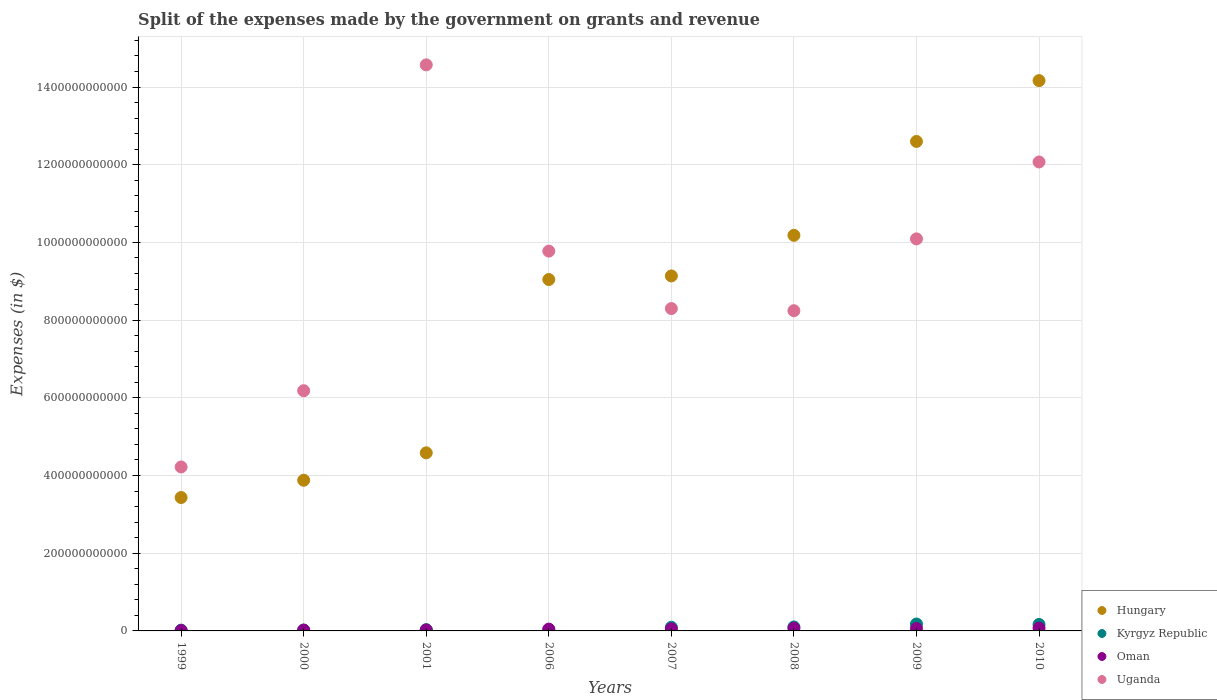How many different coloured dotlines are there?
Provide a succinct answer. 4. Is the number of dotlines equal to the number of legend labels?
Give a very brief answer. Yes. What is the expenses made by the government on grants and revenue in Oman in 1999?
Offer a terse response. 9.96e+08. Across all years, what is the maximum expenses made by the government on grants and revenue in Kyrgyz Republic?
Your answer should be compact. 1.78e+1. Across all years, what is the minimum expenses made by the government on grants and revenue in Uganda?
Give a very brief answer. 4.22e+11. In which year was the expenses made by the government on grants and revenue in Kyrgyz Republic maximum?
Make the answer very short. 2009. In which year was the expenses made by the government on grants and revenue in Kyrgyz Republic minimum?
Make the answer very short. 1999. What is the total expenses made by the government on grants and revenue in Hungary in the graph?
Ensure brevity in your answer.  6.70e+12. What is the difference between the expenses made by the government on grants and revenue in Uganda in 2000 and that in 2008?
Ensure brevity in your answer.  -2.06e+11. What is the difference between the expenses made by the government on grants and revenue in Uganda in 2006 and the expenses made by the government on grants and revenue in Hungary in 2010?
Give a very brief answer. -4.39e+11. What is the average expenses made by the government on grants and revenue in Uganda per year?
Offer a very short reply. 9.18e+11. In the year 2007, what is the difference between the expenses made by the government on grants and revenue in Uganda and expenses made by the government on grants and revenue in Oman?
Offer a very short reply. 8.24e+11. In how many years, is the expenses made by the government on grants and revenue in Oman greater than 280000000000 $?
Offer a very short reply. 0. What is the ratio of the expenses made by the government on grants and revenue in Kyrgyz Republic in 2000 to that in 2008?
Keep it short and to the point. 0.21. Is the difference between the expenses made by the government on grants and revenue in Uganda in 1999 and 2009 greater than the difference between the expenses made by the government on grants and revenue in Oman in 1999 and 2009?
Keep it short and to the point. No. What is the difference between the highest and the second highest expenses made by the government on grants and revenue in Kyrgyz Republic?
Your answer should be very brief. 1.05e+09. What is the difference between the highest and the lowest expenses made by the government on grants and revenue in Kyrgyz Republic?
Your answer should be compact. 1.57e+1. Is it the case that in every year, the sum of the expenses made by the government on grants and revenue in Oman and expenses made by the government on grants and revenue in Uganda  is greater than the expenses made by the government on grants and revenue in Kyrgyz Republic?
Ensure brevity in your answer.  Yes. Is the expenses made by the government on grants and revenue in Oman strictly less than the expenses made by the government on grants and revenue in Kyrgyz Republic over the years?
Your response must be concise. No. How many dotlines are there?
Keep it short and to the point. 4. What is the difference between two consecutive major ticks on the Y-axis?
Your response must be concise. 2.00e+11. Does the graph contain any zero values?
Ensure brevity in your answer.  No. Where does the legend appear in the graph?
Your answer should be very brief. Bottom right. What is the title of the graph?
Make the answer very short. Split of the expenses made by the government on grants and revenue. Does "Samoa" appear as one of the legend labels in the graph?
Offer a terse response. No. What is the label or title of the Y-axis?
Give a very brief answer. Expenses (in $). What is the Expenses (in $) in Hungary in 1999?
Ensure brevity in your answer.  3.43e+11. What is the Expenses (in $) of Kyrgyz Republic in 1999?
Provide a short and direct response. 2.05e+09. What is the Expenses (in $) of Oman in 1999?
Offer a terse response. 9.96e+08. What is the Expenses (in $) of Uganda in 1999?
Offer a terse response. 4.22e+11. What is the Expenses (in $) in Hungary in 2000?
Keep it short and to the point. 3.88e+11. What is the Expenses (in $) in Kyrgyz Republic in 2000?
Keep it short and to the point. 2.19e+09. What is the Expenses (in $) in Oman in 2000?
Provide a succinct answer. 2.13e+09. What is the Expenses (in $) in Uganda in 2000?
Ensure brevity in your answer.  6.18e+11. What is the Expenses (in $) in Hungary in 2001?
Your answer should be very brief. 4.58e+11. What is the Expenses (in $) of Kyrgyz Republic in 2001?
Your response must be concise. 3.29e+09. What is the Expenses (in $) of Oman in 2001?
Provide a short and direct response. 2.38e+09. What is the Expenses (in $) in Uganda in 2001?
Keep it short and to the point. 1.46e+12. What is the Expenses (in $) in Hungary in 2006?
Provide a succinct answer. 9.05e+11. What is the Expenses (in $) in Kyrgyz Republic in 2006?
Ensure brevity in your answer.  2.90e+09. What is the Expenses (in $) of Oman in 2006?
Provide a short and direct response. 4.63e+09. What is the Expenses (in $) in Uganda in 2006?
Provide a short and direct response. 9.78e+11. What is the Expenses (in $) of Hungary in 2007?
Give a very brief answer. 9.14e+11. What is the Expenses (in $) of Kyrgyz Republic in 2007?
Your answer should be very brief. 9.40e+09. What is the Expenses (in $) in Oman in 2007?
Offer a very short reply. 5.40e+09. What is the Expenses (in $) in Uganda in 2007?
Your answer should be very brief. 8.30e+11. What is the Expenses (in $) of Hungary in 2008?
Your response must be concise. 1.02e+12. What is the Expenses (in $) of Kyrgyz Republic in 2008?
Your answer should be compact. 1.03e+1. What is the Expenses (in $) in Oman in 2008?
Make the answer very short. 7.02e+09. What is the Expenses (in $) in Uganda in 2008?
Your answer should be very brief. 8.24e+11. What is the Expenses (in $) of Hungary in 2009?
Provide a short and direct response. 1.26e+12. What is the Expenses (in $) in Kyrgyz Republic in 2009?
Give a very brief answer. 1.78e+1. What is the Expenses (in $) of Oman in 2009?
Your response must be concise. 6.14e+09. What is the Expenses (in $) of Uganda in 2009?
Offer a terse response. 1.01e+12. What is the Expenses (in $) of Hungary in 2010?
Ensure brevity in your answer.  1.42e+12. What is the Expenses (in $) of Kyrgyz Republic in 2010?
Ensure brevity in your answer.  1.67e+1. What is the Expenses (in $) of Oman in 2010?
Provide a succinct answer. 7.31e+09. What is the Expenses (in $) of Uganda in 2010?
Ensure brevity in your answer.  1.21e+12. Across all years, what is the maximum Expenses (in $) in Hungary?
Keep it short and to the point. 1.42e+12. Across all years, what is the maximum Expenses (in $) of Kyrgyz Republic?
Ensure brevity in your answer.  1.78e+1. Across all years, what is the maximum Expenses (in $) of Oman?
Your answer should be compact. 7.31e+09. Across all years, what is the maximum Expenses (in $) in Uganda?
Ensure brevity in your answer.  1.46e+12. Across all years, what is the minimum Expenses (in $) of Hungary?
Offer a terse response. 3.43e+11. Across all years, what is the minimum Expenses (in $) of Kyrgyz Republic?
Your response must be concise. 2.05e+09. Across all years, what is the minimum Expenses (in $) in Oman?
Offer a very short reply. 9.96e+08. Across all years, what is the minimum Expenses (in $) in Uganda?
Your answer should be compact. 4.22e+11. What is the total Expenses (in $) in Hungary in the graph?
Give a very brief answer. 6.70e+12. What is the total Expenses (in $) of Kyrgyz Republic in the graph?
Your answer should be compact. 6.46e+1. What is the total Expenses (in $) of Oman in the graph?
Offer a terse response. 3.60e+1. What is the total Expenses (in $) of Uganda in the graph?
Provide a short and direct response. 7.35e+12. What is the difference between the Expenses (in $) in Hungary in 1999 and that in 2000?
Ensure brevity in your answer.  -4.44e+1. What is the difference between the Expenses (in $) of Kyrgyz Republic in 1999 and that in 2000?
Offer a very short reply. -1.39e+08. What is the difference between the Expenses (in $) of Oman in 1999 and that in 2000?
Provide a short and direct response. -1.13e+09. What is the difference between the Expenses (in $) in Uganda in 1999 and that in 2000?
Give a very brief answer. -1.96e+11. What is the difference between the Expenses (in $) in Hungary in 1999 and that in 2001?
Offer a very short reply. -1.15e+11. What is the difference between the Expenses (in $) in Kyrgyz Republic in 1999 and that in 2001?
Offer a very short reply. -1.24e+09. What is the difference between the Expenses (in $) of Oman in 1999 and that in 2001?
Ensure brevity in your answer.  -1.39e+09. What is the difference between the Expenses (in $) of Uganda in 1999 and that in 2001?
Provide a short and direct response. -1.04e+12. What is the difference between the Expenses (in $) in Hungary in 1999 and that in 2006?
Offer a very short reply. -5.61e+11. What is the difference between the Expenses (in $) of Kyrgyz Republic in 1999 and that in 2006?
Offer a terse response. -8.53e+08. What is the difference between the Expenses (in $) in Oman in 1999 and that in 2006?
Provide a short and direct response. -3.64e+09. What is the difference between the Expenses (in $) in Uganda in 1999 and that in 2006?
Give a very brief answer. -5.56e+11. What is the difference between the Expenses (in $) of Hungary in 1999 and that in 2007?
Provide a short and direct response. -5.70e+11. What is the difference between the Expenses (in $) of Kyrgyz Republic in 1999 and that in 2007?
Provide a short and direct response. -7.35e+09. What is the difference between the Expenses (in $) in Oman in 1999 and that in 2007?
Ensure brevity in your answer.  -4.40e+09. What is the difference between the Expenses (in $) in Uganda in 1999 and that in 2007?
Keep it short and to the point. -4.08e+11. What is the difference between the Expenses (in $) in Hungary in 1999 and that in 2008?
Provide a short and direct response. -6.75e+11. What is the difference between the Expenses (in $) of Kyrgyz Republic in 1999 and that in 2008?
Provide a succinct answer. -8.21e+09. What is the difference between the Expenses (in $) in Oman in 1999 and that in 2008?
Your response must be concise. -6.02e+09. What is the difference between the Expenses (in $) in Uganda in 1999 and that in 2008?
Your answer should be compact. -4.02e+11. What is the difference between the Expenses (in $) in Hungary in 1999 and that in 2009?
Offer a terse response. -9.17e+11. What is the difference between the Expenses (in $) in Kyrgyz Republic in 1999 and that in 2009?
Your answer should be compact. -1.57e+1. What is the difference between the Expenses (in $) of Oman in 1999 and that in 2009?
Your answer should be very brief. -5.14e+09. What is the difference between the Expenses (in $) of Uganda in 1999 and that in 2009?
Offer a terse response. -5.87e+11. What is the difference between the Expenses (in $) in Hungary in 1999 and that in 2010?
Ensure brevity in your answer.  -1.07e+12. What is the difference between the Expenses (in $) in Kyrgyz Republic in 1999 and that in 2010?
Your response must be concise. -1.47e+1. What is the difference between the Expenses (in $) in Oman in 1999 and that in 2010?
Provide a succinct answer. -6.31e+09. What is the difference between the Expenses (in $) in Uganda in 1999 and that in 2010?
Keep it short and to the point. -7.85e+11. What is the difference between the Expenses (in $) of Hungary in 2000 and that in 2001?
Keep it short and to the point. -7.05e+1. What is the difference between the Expenses (in $) of Kyrgyz Republic in 2000 and that in 2001?
Provide a short and direct response. -1.11e+09. What is the difference between the Expenses (in $) in Oman in 2000 and that in 2001?
Offer a terse response. -2.54e+08. What is the difference between the Expenses (in $) of Uganda in 2000 and that in 2001?
Your answer should be compact. -8.39e+11. What is the difference between the Expenses (in $) in Hungary in 2000 and that in 2006?
Make the answer very short. -5.17e+11. What is the difference between the Expenses (in $) of Kyrgyz Republic in 2000 and that in 2006?
Your answer should be compact. -7.14e+08. What is the difference between the Expenses (in $) in Oman in 2000 and that in 2006?
Provide a short and direct response. -2.51e+09. What is the difference between the Expenses (in $) of Uganda in 2000 and that in 2006?
Provide a succinct answer. -3.59e+11. What is the difference between the Expenses (in $) of Hungary in 2000 and that in 2007?
Ensure brevity in your answer.  -5.26e+11. What is the difference between the Expenses (in $) in Kyrgyz Republic in 2000 and that in 2007?
Offer a terse response. -7.21e+09. What is the difference between the Expenses (in $) of Oman in 2000 and that in 2007?
Your answer should be compact. -3.27e+09. What is the difference between the Expenses (in $) in Uganda in 2000 and that in 2007?
Offer a terse response. -2.11e+11. What is the difference between the Expenses (in $) in Hungary in 2000 and that in 2008?
Provide a short and direct response. -6.30e+11. What is the difference between the Expenses (in $) in Kyrgyz Republic in 2000 and that in 2008?
Give a very brief answer. -8.07e+09. What is the difference between the Expenses (in $) of Oman in 2000 and that in 2008?
Offer a terse response. -4.89e+09. What is the difference between the Expenses (in $) of Uganda in 2000 and that in 2008?
Your response must be concise. -2.06e+11. What is the difference between the Expenses (in $) of Hungary in 2000 and that in 2009?
Keep it short and to the point. -8.72e+11. What is the difference between the Expenses (in $) of Kyrgyz Republic in 2000 and that in 2009?
Your answer should be compact. -1.56e+1. What is the difference between the Expenses (in $) of Oman in 2000 and that in 2009?
Make the answer very short. -4.01e+09. What is the difference between the Expenses (in $) of Uganda in 2000 and that in 2009?
Your answer should be very brief. -3.91e+11. What is the difference between the Expenses (in $) of Hungary in 2000 and that in 2010?
Ensure brevity in your answer.  -1.03e+12. What is the difference between the Expenses (in $) of Kyrgyz Republic in 2000 and that in 2010?
Your answer should be compact. -1.45e+1. What is the difference between the Expenses (in $) in Oman in 2000 and that in 2010?
Ensure brevity in your answer.  -5.18e+09. What is the difference between the Expenses (in $) in Uganda in 2000 and that in 2010?
Keep it short and to the point. -5.89e+11. What is the difference between the Expenses (in $) in Hungary in 2001 and that in 2006?
Give a very brief answer. -4.46e+11. What is the difference between the Expenses (in $) in Kyrgyz Republic in 2001 and that in 2006?
Provide a short and direct response. 3.91e+08. What is the difference between the Expenses (in $) in Oman in 2001 and that in 2006?
Your answer should be compact. -2.25e+09. What is the difference between the Expenses (in $) of Uganda in 2001 and that in 2006?
Your answer should be very brief. 4.79e+11. What is the difference between the Expenses (in $) in Hungary in 2001 and that in 2007?
Your answer should be very brief. -4.55e+11. What is the difference between the Expenses (in $) in Kyrgyz Republic in 2001 and that in 2007?
Make the answer very short. -6.11e+09. What is the difference between the Expenses (in $) of Oman in 2001 and that in 2007?
Provide a succinct answer. -3.02e+09. What is the difference between the Expenses (in $) of Uganda in 2001 and that in 2007?
Ensure brevity in your answer.  6.27e+11. What is the difference between the Expenses (in $) in Hungary in 2001 and that in 2008?
Your answer should be very brief. -5.60e+11. What is the difference between the Expenses (in $) in Kyrgyz Republic in 2001 and that in 2008?
Your answer should be very brief. -6.97e+09. What is the difference between the Expenses (in $) in Oman in 2001 and that in 2008?
Make the answer very short. -4.64e+09. What is the difference between the Expenses (in $) of Uganda in 2001 and that in 2008?
Ensure brevity in your answer.  6.33e+11. What is the difference between the Expenses (in $) of Hungary in 2001 and that in 2009?
Your answer should be very brief. -8.02e+11. What is the difference between the Expenses (in $) in Kyrgyz Republic in 2001 and that in 2009?
Your answer should be very brief. -1.45e+1. What is the difference between the Expenses (in $) in Oman in 2001 and that in 2009?
Keep it short and to the point. -3.76e+09. What is the difference between the Expenses (in $) in Uganda in 2001 and that in 2009?
Your answer should be compact. 4.48e+11. What is the difference between the Expenses (in $) in Hungary in 2001 and that in 2010?
Offer a very short reply. -9.58e+11. What is the difference between the Expenses (in $) in Kyrgyz Republic in 2001 and that in 2010?
Your answer should be compact. -1.34e+1. What is the difference between the Expenses (in $) in Oman in 2001 and that in 2010?
Provide a short and direct response. -4.92e+09. What is the difference between the Expenses (in $) in Uganda in 2001 and that in 2010?
Offer a terse response. 2.50e+11. What is the difference between the Expenses (in $) in Hungary in 2006 and that in 2007?
Your answer should be very brief. -9.26e+09. What is the difference between the Expenses (in $) in Kyrgyz Republic in 2006 and that in 2007?
Ensure brevity in your answer.  -6.50e+09. What is the difference between the Expenses (in $) in Oman in 2006 and that in 2007?
Give a very brief answer. -7.66e+08. What is the difference between the Expenses (in $) in Uganda in 2006 and that in 2007?
Give a very brief answer. 1.48e+11. What is the difference between the Expenses (in $) in Hungary in 2006 and that in 2008?
Your answer should be very brief. -1.14e+11. What is the difference between the Expenses (in $) in Kyrgyz Republic in 2006 and that in 2008?
Your response must be concise. -7.36e+09. What is the difference between the Expenses (in $) of Oman in 2006 and that in 2008?
Your response must be concise. -2.38e+09. What is the difference between the Expenses (in $) of Uganda in 2006 and that in 2008?
Your answer should be very brief. 1.53e+11. What is the difference between the Expenses (in $) of Hungary in 2006 and that in 2009?
Ensure brevity in your answer.  -3.55e+11. What is the difference between the Expenses (in $) in Kyrgyz Republic in 2006 and that in 2009?
Your answer should be compact. -1.48e+1. What is the difference between the Expenses (in $) in Oman in 2006 and that in 2009?
Ensure brevity in your answer.  -1.50e+09. What is the difference between the Expenses (in $) in Uganda in 2006 and that in 2009?
Your answer should be compact. -3.15e+1. What is the difference between the Expenses (in $) of Hungary in 2006 and that in 2010?
Offer a terse response. -5.12e+11. What is the difference between the Expenses (in $) of Kyrgyz Republic in 2006 and that in 2010?
Provide a short and direct response. -1.38e+1. What is the difference between the Expenses (in $) in Oman in 2006 and that in 2010?
Ensure brevity in your answer.  -2.67e+09. What is the difference between the Expenses (in $) of Uganda in 2006 and that in 2010?
Offer a terse response. -2.30e+11. What is the difference between the Expenses (in $) of Hungary in 2007 and that in 2008?
Offer a terse response. -1.04e+11. What is the difference between the Expenses (in $) in Kyrgyz Republic in 2007 and that in 2008?
Provide a short and direct response. -8.59e+08. What is the difference between the Expenses (in $) in Oman in 2007 and that in 2008?
Make the answer very short. -1.62e+09. What is the difference between the Expenses (in $) in Uganda in 2007 and that in 2008?
Offer a terse response. 5.56e+09. What is the difference between the Expenses (in $) in Hungary in 2007 and that in 2009?
Provide a short and direct response. -3.46e+11. What is the difference between the Expenses (in $) of Kyrgyz Republic in 2007 and that in 2009?
Give a very brief answer. -8.35e+09. What is the difference between the Expenses (in $) in Oman in 2007 and that in 2009?
Offer a very short reply. -7.37e+08. What is the difference between the Expenses (in $) of Uganda in 2007 and that in 2009?
Keep it short and to the point. -1.79e+11. What is the difference between the Expenses (in $) in Hungary in 2007 and that in 2010?
Offer a very short reply. -5.03e+11. What is the difference between the Expenses (in $) in Kyrgyz Republic in 2007 and that in 2010?
Offer a very short reply. -7.30e+09. What is the difference between the Expenses (in $) of Oman in 2007 and that in 2010?
Your answer should be compact. -1.90e+09. What is the difference between the Expenses (in $) in Uganda in 2007 and that in 2010?
Give a very brief answer. -3.77e+11. What is the difference between the Expenses (in $) of Hungary in 2008 and that in 2009?
Keep it short and to the point. -2.42e+11. What is the difference between the Expenses (in $) in Kyrgyz Republic in 2008 and that in 2009?
Offer a very short reply. -7.49e+09. What is the difference between the Expenses (in $) of Oman in 2008 and that in 2009?
Ensure brevity in your answer.  8.79e+08. What is the difference between the Expenses (in $) of Uganda in 2008 and that in 2009?
Make the answer very short. -1.85e+11. What is the difference between the Expenses (in $) in Hungary in 2008 and that in 2010?
Offer a very short reply. -3.98e+11. What is the difference between the Expenses (in $) of Kyrgyz Republic in 2008 and that in 2010?
Keep it short and to the point. -6.44e+09. What is the difference between the Expenses (in $) in Oman in 2008 and that in 2010?
Provide a short and direct response. -2.88e+08. What is the difference between the Expenses (in $) in Uganda in 2008 and that in 2010?
Offer a terse response. -3.83e+11. What is the difference between the Expenses (in $) of Hungary in 2009 and that in 2010?
Make the answer very short. -1.57e+11. What is the difference between the Expenses (in $) in Kyrgyz Republic in 2009 and that in 2010?
Offer a very short reply. 1.05e+09. What is the difference between the Expenses (in $) in Oman in 2009 and that in 2010?
Offer a terse response. -1.17e+09. What is the difference between the Expenses (in $) of Uganda in 2009 and that in 2010?
Provide a short and direct response. -1.98e+11. What is the difference between the Expenses (in $) of Hungary in 1999 and the Expenses (in $) of Kyrgyz Republic in 2000?
Give a very brief answer. 3.41e+11. What is the difference between the Expenses (in $) in Hungary in 1999 and the Expenses (in $) in Oman in 2000?
Your answer should be very brief. 3.41e+11. What is the difference between the Expenses (in $) in Hungary in 1999 and the Expenses (in $) in Uganda in 2000?
Keep it short and to the point. -2.75e+11. What is the difference between the Expenses (in $) of Kyrgyz Republic in 1999 and the Expenses (in $) of Oman in 2000?
Offer a very short reply. -7.81e+07. What is the difference between the Expenses (in $) of Kyrgyz Republic in 1999 and the Expenses (in $) of Uganda in 2000?
Your answer should be compact. -6.16e+11. What is the difference between the Expenses (in $) of Oman in 1999 and the Expenses (in $) of Uganda in 2000?
Give a very brief answer. -6.17e+11. What is the difference between the Expenses (in $) in Hungary in 1999 and the Expenses (in $) in Kyrgyz Republic in 2001?
Provide a short and direct response. 3.40e+11. What is the difference between the Expenses (in $) of Hungary in 1999 and the Expenses (in $) of Oman in 2001?
Provide a succinct answer. 3.41e+11. What is the difference between the Expenses (in $) of Hungary in 1999 and the Expenses (in $) of Uganda in 2001?
Give a very brief answer. -1.11e+12. What is the difference between the Expenses (in $) in Kyrgyz Republic in 1999 and the Expenses (in $) in Oman in 2001?
Your answer should be very brief. -3.32e+08. What is the difference between the Expenses (in $) in Kyrgyz Republic in 1999 and the Expenses (in $) in Uganda in 2001?
Ensure brevity in your answer.  -1.45e+12. What is the difference between the Expenses (in $) of Oman in 1999 and the Expenses (in $) of Uganda in 2001?
Ensure brevity in your answer.  -1.46e+12. What is the difference between the Expenses (in $) of Hungary in 1999 and the Expenses (in $) of Kyrgyz Republic in 2006?
Your answer should be compact. 3.40e+11. What is the difference between the Expenses (in $) of Hungary in 1999 and the Expenses (in $) of Oman in 2006?
Provide a succinct answer. 3.39e+11. What is the difference between the Expenses (in $) in Hungary in 1999 and the Expenses (in $) in Uganda in 2006?
Keep it short and to the point. -6.34e+11. What is the difference between the Expenses (in $) of Kyrgyz Republic in 1999 and the Expenses (in $) of Oman in 2006?
Your answer should be compact. -2.58e+09. What is the difference between the Expenses (in $) of Kyrgyz Republic in 1999 and the Expenses (in $) of Uganda in 2006?
Offer a very short reply. -9.76e+11. What is the difference between the Expenses (in $) of Oman in 1999 and the Expenses (in $) of Uganda in 2006?
Provide a succinct answer. -9.77e+11. What is the difference between the Expenses (in $) of Hungary in 1999 and the Expenses (in $) of Kyrgyz Republic in 2007?
Keep it short and to the point. 3.34e+11. What is the difference between the Expenses (in $) of Hungary in 1999 and the Expenses (in $) of Oman in 2007?
Make the answer very short. 3.38e+11. What is the difference between the Expenses (in $) of Hungary in 1999 and the Expenses (in $) of Uganda in 2007?
Offer a terse response. -4.86e+11. What is the difference between the Expenses (in $) in Kyrgyz Republic in 1999 and the Expenses (in $) in Oman in 2007?
Your answer should be very brief. -3.35e+09. What is the difference between the Expenses (in $) in Kyrgyz Republic in 1999 and the Expenses (in $) in Uganda in 2007?
Your answer should be compact. -8.28e+11. What is the difference between the Expenses (in $) of Oman in 1999 and the Expenses (in $) of Uganda in 2007?
Make the answer very short. -8.29e+11. What is the difference between the Expenses (in $) of Hungary in 1999 and the Expenses (in $) of Kyrgyz Republic in 2008?
Your response must be concise. 3.33e+11. What is the difference between the Expenses (in $) of Hungary in 1999 and the Expenses (in $) of Oman in 2008?
Your answer should be compact. 3.36e+11. What is the difference between the Expenses (in $) of Hungary in 1999 and the Expenses (in $) of Uganda in 2008?
Provide a succinct answer. -4.81e+11. What is the difference between the Expenses (in $) of Kyrgyz Republic in 1999 and the Expenses (in $) of Oman in 2008?
Offer a very short reply. -4.97e+09. What is the difference between the Expenses (in $) of Kyrgyz Republic in 1999 and the Expenses (in $) of Uganda in 2008?
Your answer should be compact. -8.22e+11. What is the difference between the Expenses (in $) of Oman in 1999 and the Expenses (in $) of Uganda in 2008?
Ensure brevity in your answer.  -8.23e+11. What is the difference between the Expenses (in $) of Hungary in 1999 and the Expenses (in $) of Kyrgyz Republic in 2009?
Provide a succinct answer. 3.26e+11. What is the difference between the Expenses (in $) of Hungary in 1999 and the Expenses (in $) of Oman in 2009?
Offer a very short reply. 3.37e+11. What is the difference between the Expenses (in $) in Hungary in 1999 and the Expenses (in $) in Uganda in 2009?
Make the answer very short. -6.66e+11. What is the difference between the Expenses (in $) of Kyrgyz Republic in 1999 and the Expenses (in $) of Oman in 2009?
Give a very brief answer. -4.09e+09. What is the difference between the Expenses (in $) of Kyrgyz Republic in 1999 and the Expenses (in $) of Uganda in 2009?
Provide a succinct answer. -1.01e+12. What is the difference between the Expenses (in $) in Oman in 1999 and the Expenses (in $) in Uganda in 2009?
Offer a terse response. -1.01e+12. What is the difference between the Expenses (in $) in Hungary in 1999 and the Expenses (in $) in Kyrgyz Republic in 2010?
Ensure brevity in your answer.  3.27e+11. What is the difference between the Expenses (in $) of Hungary in 1999 and the Expenses (in $) of Oman in 2010?
Offer a terse response. 3.36e+11. What is the difference between the Expenses (in $) of Hungary in 1999 and the Expenses (in $) of Uganda in 2010?
Your response must be concise. -8.64e+11. What is the difference between the Expenses (in $) in Kyrgyz Republic in 1999 and the Expenses (in $) in Oman in 2010?
Your answer should be very brief. -5.26e+09. What is the difference between the Expenses (in $) of Kyrgyz Republic in 1999 and the Expenses (in $) of Uganda in 2010?
Provide a succinct answer. -1.21e+12. What is the difference between the Expenses (in $) in Oman in 1999 and the Expenses (in $) in Uganda in 2010?
Your answer should be very brief. -1.21e+12. What is the difference between the Expenses (in $) of Hungary in 2000 and the Expenses (in $) of Kyrgyz Republic in 2001?
Keep it short and to the point. 3.85e+11. What is the difference between the Expenses (in $) in Hungary in 2000 and the Expenses (in $) in Oman in 2001?
Ensure brevity in your answer.  3.85e+11. What is the difference between the Expenses (in $) of Hungary in 2000 and the Expenses (in $) of Uganda in 2001?
Give a very brief answer. -1.07e+12. What is the difference between the Expenses (in $) in Kyrgyz Republic in 2000 and the Expenses (in $) in Oman in 2001?
Your answer should be very brief. -1.93e+08. What is the difference between the Expenses (in $) of Kyrgyz Republic in 2000 and the Expenses (in $) of Uganda in 2001?
Your answer should be compact. -1.45e+12. What is the difference between the Expenses (in $) in Oman in 2000 and the Expenses (in $) in Uganda in 2001?
Ensure brevity in your answer.  -1.45e+12. What is the difference between the Expenses (in $) in Hungary in 2000 and the Expenses (in $) in Kyrgyz Republic in 2006?
Give a very brief answer. 3.85e+11. What is the difference between the Expenses (in $) in Hungary in 2000 and the Expenses (in $) in Oman in 2006?
Provide a succinct answer. 3.83e+11. What is the difference between the Expenses (in $) in Hungary in 2000 and the Expenses (in $) in Uganda in 2006?
Keep it short and to the point. -5.90e+11. What is the difference between the Expenses (in $) in Kyrgyz Republic in 2000 and the Expenses (in $) in Oman in 2006?
Your answer should be very brief. -2.45e+09. What is the difference between the Expenses (in $) of Kyrgyz Republic in 2000 and the Expenses (in $) of Uganda in 2006?
Make the answer very short. -9.75e+11. What is the difference between the Expenses (in $) of Oman in 2000 and the Expenses (in $) of Uganda in 2006?
Make the answer very short. -9.75e+11. What is the difference between the Expenses (in $) in Hungary in 2000 and the Expenses (in $) in Kyrgyz Republic in 2007?
Your response must be concise. 3.78e+11. What is the difference between the Expenses (in $) of Hungary in 2000 and the Expenses (in $) of Oman in 2007?
Your response must be concise. 3.82e+11. What is the difference between the Expenses (in $) in Hungary in 2000 and the Expenses (in $) in Uganda in 2007?
Your answer should be very brief. -4.42e+11. What is the difference between the Expenses (in $) in Kyrgyz Republic in 2000 and the Expenses (in $) in Oman in 2007?
Provide a short and direct response. -3.21e+09. What is the difference between the Expenses (in $) of Kyrgyz Republic in 2000 and the Expenses (in $) of Uganda in 2007?
Your answer should be very brief. -8.28e+11. What is the difference between the Expenses (in $) of Oman in 2000 and the Expenses (in $) of Uganda in 2007?
Your answer should be very brief. -8.28e+11. What is the difference between the Expenses (in $) of Hungary in 2000 and the Expenses (in $) of Kyrgyz Republic in 2008?
Provide a short and direct response. 3.78e+11. What is the difference between the Expenses (in $) of Hungary in 2000 and the Expenses (in $) of Oman in 2008?
Keep it short and to the point. 3.81e+11. What is the difference between the Expenses (in $) in Hungary in 2000 and the Expenses (in $) in Uganda in 2008?
Provide a short and direct response. -4.36e+11. What is the difference between the Expenses (in $) in Kyrgyz Republic in 2000 and the Expenses (in $) in Oman in 2008?
Give a very brief answer. -4.83e+09. What is the difference between the Expenses (in $) in Kyrgyz Republic in 2000 and the Expenses (in $) in Uganda in 2008?
Offer a very short reply. -8.22e+11. What is the difference between the Expenses (in $) of Oman in 2000 and the Expenses (in $) of Uganda in 2008?
Make the answer very short. -8.22e+11. What is the difference between the Expenses (in $) of Hungary in 2000 and the Expenses (in $) of Kyrgyz Republic in 2009?
Give a very brief answer. 3.70e+11. What is the difference between the Expenses (in $) of Hungary in 2000 and the Expenses (in $) of Oman in 2009?
Your response must be concise. 3.82e+11. What is the difference between the Expenses (in $) of Hungary in 2000 and the Expenses (in $) of Uganda in 2009?
Offer a terse response. -6.21e+11. What is the difference between the Expenses (in $) in Kyrgyz Republic in 2000 and the Expenses (in $) in Oman in 2009?
Offer a very short reply. -3.95e+09. What is the difference between the Expenses (in $) in Kyrgyz Republic in 2000 and the Expenses (in $) in Uganda in 2009?
Offer a terse response. -1.01e+12. What is the difference between the Expenses (in $) of Oman in 2000 and the Expenses (in $) of Uganda in 2009?
Your answer should be compact. -1.01e+12. What is the difference between the Expenses (in $) in Hungary in 2000 and the Expenses (in $) in Kyrgyz Republic in 2010?
Your answer should be very brief. 3.71e+11. What is the difference between the Expenses (in $) in Hungary in 2000 and the Expenses (in $) in Oman in 2010?
Your answer should be very brief. 3.81e+11. What is the difference between the Expenses (in $) of Hungary in 2000 and the Expenses (in $) of Uganda in 2010?
Keep it short and to the point. -8.19e+11. What is the difference between the Expenses (in $) of Kyrgyz Republic in 2000 and the Expenses (in $) of Oman in 2010?
Provide a succinct answer. -5.12e+09. What is the difference between the Expenses (in $) in Kyrgyz Republic in 2000 and the Expenses (in $) in Uganda in 2010?
Ensure brevity in your answer.  -1.20e+12. What is the difference between the Expenses (in $) in Oman in 2000 and the Expenses (in $) in Uganda in 2010?
Give a very brief answer. -1.21e+12. What is the difference between the Expenses (in $) of Hungary in 2001 and the Expenses (in $) of Kyrgyz Republic in 2006?
Offer a very short reply. 4.55e+11. What is the difference between the Expenses (in $) of Hungary in 2001 and the Expenses (in $) of Oman in 2006?
Your answer should be very brief. 4.54e+11. What is the difference between the Expenses (in $) of Hungary in 2001 and the Expenses (in $) of Uganda in 2006?
Keep it short and to the point. -5.19e+11. What is the difference between the Expenses (in $) in Kyrgyz Republic in 2001 and the Expenses (in $) in Oman in 2006?
Your answer should be very brief. -1.34e+09. What is the difference between the Expenses (in $) of Kyrgyz Republic in 2001 and the Expenses (in $) of Uganda in 2006?
Give a very brief answer. -9.74e+11. What is the difference between the Expenses (in $) of Oman in 2001 and the Expenses (in $) of Uganda in 2006?
Your response must be concise. -9.75e+11. What is the difference between the Expenses (in $) of Hungary in 2001 and the Expenses (in $) of Kyrgyz Republic in 2007?
Provide a short and direct response. 4.49e+11. What is the difference between the Expenses (in $) in Hungary in 2001 and the Expenses (in $) in Oman in 2007?
Your response must be concise. 4.53e+11. What is the difference between the Expenses (in $) of Hungary in 2001 and the Expenses (in $) of Uganda in 2007?
Provide a succinct answer. -3.71e+11. What is the difference between the Expenses (in $) of Kyrgyz Republic in 2001 and the Expenses (in $) of Oman in 2007?
Your answer should be compact. -2.11e+09. What is the difference between the Expenses (in $) in Kyrgyz Republic in 2001 and the Expenses (in $) in Uganda in 2007?
Provide a succinct answer. -8.26e+11. What is the difference between the Expenses (in $) in Oman in 2001 and the Expenses (in $) in Uganda in 2007?
Make the answer very short. -8.27e+11. What is the difference between the Expenses (in $) of Hungary in 2001 and the Expenses (in $) of Kyrgyz Republic in 2008?
Provide a succinct answer. 4.48e+11. What is the difference between the Expenses (in $) in Hungary in 2001 and the Expenses (in $) in Oman in 2008?
Provide a short and direct response. 4.51e+11. What is the difference between the Expenses (in $) in Hungary in 2001 and the Expenses (in $) in Uganda in 2008?
Provide a short and direct response. -3.66e+11. What is the difference between the Expenses (in $) of Kyrgyz Republic in 2001 and the Expenses (in $) of Oman in 2008?
Provide a short and direct response. -3.72e+09. What is the difference between the Expenses (in $) in Kyrgyz Republic in 2001 and the Expenses (in $) in Uganda in 2008?
Ensure brevity in your answer.  -8.21e+11. What is the difference between the Expenses (in $) of Oman in 2001 and the Expenses (in $) of Uganda in 2008?
Ensure brevity in your answer.  -8.22e+11. What is the difference between the Expenses (in $) in Hungary in 2001 and the Expenses (in $) in Kyrgyz Republic in 2009?
Ensure brevity in your answer.  4.41e+11. What is the difference between the Expenses (in $) of Hungary in 2001 and the Expenses (in $) of Oman in 2009?
Keep it short and to the point. 4.52e+11. What is the difference between the Expenses (in $) in Hungary in 2001 and the Expenses (in $) in Uganda in 2009?
Offer a terse response. -5.51e+11. What is the difference between the Expenses (in $) in Kyrgyz Republic in 2001 and the Expenses (in $) in Oman in 2009?
Your answer should be very brief. -2.84e+09. What is the difference between the Expenses (in $) in Kyrgyz Republic in 2001 and the Expenses (in $) in Uganda in 2009?
Offer a very short reply. -1.01e+12. What is the difference between the Expenses (in $) in Oman in 2001 and the Expenses (in $) in Uganda in 2009?
Give a very brief answer. -1.01e+12. What is the difference between the Expenses (in $) of Hungary in 2001 and the Expenses (in $) of Kyrgyz Republic in 2010?
Provide a short and direct response. 4.42e+11. What is the difference between the Expenses (in $) of Hungary in 2001 and the Expenses (in $) of Oman in 2010?
Your response must be concise. 4.51e+11. What is the difference between the Expenses (in $) in Hungary in 2001 and the Expenses (in $) in Uganda in 2010?
Offer a very short reply. -7.49e+11. What is the difference between the Expenses (in $) of Kyrgyz Republic in 2001 and the Expenses (in $) of Oman in 2010?
Offer a very short reply. -4.01e+09. What is the difference between the Expenses (in $) in Kyrgyz Republic in 2001 and the Expenses (in $) in Uganda in 2010?
Your answer should be very brief. -1.20e+12. What is the difference between the Expenses (in $) of Oman in 2001 and the Expenses (in $) of Uganda in 2010?
Ensure brevity in your answer.  -1.20e+12. What is the difference between the Expenses (in $) of Hungary in 2006 and the Expenses (in $) of Kyrgyz Republic in 2007?
Keep it short and to the point. 8.95e+11. What is the difference between the Expenses (in $) in Hungary in 2006 and the Expenses (in $) in Oman in 2007?
Your answer should be very brief. 8.99e+11. What is the difference between the Expenses (in $) of Hungary in 2006 and the Expenses (in $) of Uganda in 2007?
Your answer should be compact. 7.48e+1. What is the difference between the Expenses (in $) in Kyrgyz Republic in 2006 and the Expenses (in $) in Oman in 2007?
Your response must be concise. -2.50e+09. What is the difference between the Expenses (in $) in Kyrgyz Republic in 2006 and the Expenses (in $) in Uganda in 2007?
Make the answer very short. -8.27e+11. What is the difference between the Expenses (in $) in Oman in 2006 and the Expenses (in $) in Uganda in 2007?
Offer a terse response. -8.25e+11. What is the difference between the Expenses (in $) in Hungary in 2006 and the Expenses (in $) in Kyrgyz Republic in 2008?
Your answer should be compact. 8.94e+11. What is the difference between the Expenses (in $) of Hungary in 2006 and the Expenses (in $) of Oman in 2008?
Your response must be concise. 8.98e+11. What is the difference between the Expenses (in $) in Hungary in 2006 and the Expenses (in $) in Uganda in 2008?
Give a very brief answer. 8.03e+1. What is the difference between the Expenses (in $) in Kyrgyz Republic in 2006 and the Expenses (in $) in Oman in 2008?
Make the answer very short. -4.11e+09. What is the difference between the Expenses (in $) of Kyrgyz Republic in 2006 and the Expenses (in $) of Uganda in 2008?
Your response must be concise. -8.21e+11. What is the difference between the Expenses (in $) of Oman in 2006 and the Expenses (in $) of Uganda in 2008?
Offer a very short reply. -8.20e+11. What is the difference between the Expenses (in $) of Hungary in 2006 and the Expenses (in $) of Kyrgyz Republic in 2009?
Your response must be concise. 8.87e+11. What is the difference between the Expenses (in $) of Hungary in 2006 and the Expenses (in $) of Oman in 2009?
Give a very brief answer. 8.98e+11. What is the difference between the Expenses (in $) in Hungary in 2006 and the Expenses (in $) in Uganda in 2009?
Ensure brevity in your answer.  -1.05e+11. What is the difference between the Expenses (in $) in Kyrgyz Republic in 2006 and the Expenses (in $) in Oman in 2009?
Keep it short and to the point. -3.23e+09. What is the difference between the Expenses (in $) of Kyrgyz Republic in 2006 and the Expenses (in $) of Uganda in 2009?
Give a very brief answer. -1.01e+12. What is the difference between the Expenses (in $) in Oman in 2006 and the Expenses (in $) in Uganda in 2009?
Ensure brevity in your answer.  -1.00e+12. What is the difference between the Expenses (in $) of Hungary in 2006 and the Expenses (in $) of Kyrgyz Republic in 2010?
Offer a terse response. 8.88e+11. What is the difference between the Expenses (in $) in Hungary in 2006 and the Expenses (in $) in Oman in 2010?
Offer a terse response. 8.97e+11. What is the difference between the Expenses (in $) of Hungary in 2006 and the Expenses (in $) of Uganda in 2010?
Keep it short and to the point. -3.03e+11. What is the difference between the Expenses (in $) in Kyrgyz Republic in 2006 and the Expenses (in $) in Oman in 2010?
Keep it short and to the point. -4.40e+09. What is the difference between the Expenses (in $) in Kyrgyz Republic in 2006 and the Expenses (in $) in Uganda in 2010?
Make the answer very short. -1.20e+12. What is the difference between the Expenses (in $) in Oman in 2006 and the Expenses (in $) in Uganda in 2010?
Provide a short and direct response. -1.20e+12. What is the difference between the Expenses (in $) of Hungary in 2007 and the Expenses (in $) of Kyrgyz Republic in 2008?
Your response must be concise. 9.04e+11. What is the difference between the Expenses (in $) of Hungary in 2007 and the Expenses (in $) of Oman in 2008?
Provide a succinct answer. 9.07e+11. What is the difference between the Expenses (in $) in Hungary in 2007 and the Expenses (in $) in Uganda in 2008?
Provide a short and direct response. 8.96e+1. What is the difference between the Expenses (in $) in Kyrgyz Republic in 2007 and the Expenses (in $) in Oman in 2008?
Your response must be concise. 2.39e+09. What is the difference between the Expenses (in $) of Kyrgyz Republic in 2007 and the Expenses (in $) of Uganda in 2008?
Give a very brief answer. -8.15e+11. What is the difference between the Expenses (in $) of Oman in 2007 and the Expenses (in $) of Uganda in 2008?
Ensure brevity in your answer.  -8.19e+11. What is the difference between the Expenses (in $) in Hungary in 2007 and the Expenses (in $) in Kyrgyz Republic in 2009?
Provide a succinct answer. 8.96e+11. What is the difference between the Expenses (in $) in Hungary in 2007 and the Expenses (in $) in Oman in 2009?
Make the answer very short. 9.08e+11. What is the difference between the Expenses (in $) in Hungary in 2007 and the Expenses (in $) in Uganda in 2009?
Provide a short and direct response. -9.53e+1. What is the difference between the Expenses (in $) in Kyrgyz Republic in 2007 and the Expenses (in $) in Oman in 2009?
Your response must be concise. 3.27e+09. What is the difference between the Expenses (in $) of Kyrgyz Republic in 2007 and the Expenses (in $) of Uganda in 2009?
Your answer should be compact. -1.00e+12. What is the difference between the Expenses (in $) of Oman in 2007 and the Expenses (in $) of Uganda in 2009?
Ensure brevity in your answer.  -1.00e+12. What is the difference between the Expenses (in $) in Hungary in 2007 and the Expenses (in $) in Kyrgyz Republic in 2010?
Provide a succinct answer. 8.97e+11. What is the difference between the Expenses (in $) in Hungary in 2007 and the Expenses (in $) in Oman in 2010?
Ensure brevity in your answer.  9.06e+11. What is the difference between the Expenses (in $) in Hungary in 2007 and the Expenses (in $) in Uganda in 2010?
Give a very brief answer. -2.93e+11. What is the difference between the Expenses (in $) in Kyrgyz Republic in 2007 and the Expenses (in $) in Oman in 2010?
Provide a short and direct response. 2.10e+09. What is the difference between the Expenses (in $) in Kyrgyz Republic in 2007 and the Expenses (in $) in Uganda in 2010?
Give a very brief answer. -1.20e+12. What is the difference between the Expenses (in $) of Oman in 2007 and the Expenses (in $) of Uganda in 2010?
Offer a very short reply. -1.20e+12. What is the difference between the Expenses (in $) in Hungary in 2008 and the Expenses (in $) in Kyrgyz Republic in 2009?
Ensure brevity in your answer.  1.00e+12. What is the difference between the Expenses (in $) of Hungary in 2008 and the Expenses (in $) of Oman in 2009?
Offer a terse response. 1.01e+12. What is the difference between the Expenses (in $) of Hungary in 2008 and the Expenses (in $) of Uganda in 2009?
Keep it short and to the point. 9.18e+09. What is the difference between the Expenses (in $) in Kyrgyz Republic in 2008 and the Expenses (in $) in Oman in 2009?
Provide a short and direct response. 4.12e+09. What is the difference between the Expenses (in $) in Kyrgyz Republic in 2008 and the Expenses (in $) in Uganda in 2009?
Your answer should be very brief. -9.99e+11. What is the difference between the Expenses (in $) of Oman in 2008 and the Expenses (in $) of Uganda in 2009?
Ensure brevity in your answer.  -1.00e+12. What is the difference between the Expenses (in $) in Hungary in 2008 and the Expenses (in $) in Kyrgyz Republic in 2010?
Keep it short and to the point. 1.00e+12. What is the difference between the Expenses (in $) of Hungary in 2008 and the Expenses (in $) of Oman in 2010?
Make the answer very short. 1.01e+12. What is the difference between the Expenses (in $) in Hungary in 2008 and the Expenses (in $) in Uganda in 2010?
Make the answer very short. -1.89e+11. What is the difference between the Expenses (in $) of Kyrgyz Republic in 2008 and the Expenses (in $) of Oman in 2010?
Give a very brief answer. 2.96e+09. What is the difference between the Expenses (in $) of Kyrgyz Republic in 2008 and the Expenses (in $) of Uganda in 2010?
Ensure brevity in your answer.  -1.20e+12. What is the difference between the Expenses (in $) in Oman in 2008 and the Expenses (in $) in Uganda in 2010?
Keep it short and to the point. -1.20e+12. What is the difference between the Expenses (in $) in Hungary in 2009 and the Expenses (in $) in Kyrgyz Republic in 2010?
Offer a terse response. 1.24e+12. What is the difference between the Expenses (in $) in Hungary in 2009 and the Expenses (in $) in Oman in 2010?
Provide a succinct answer. 1.25e+12. What is the difference between the Expenses (in $) of Hungary in 2009 and the Expenses (in $) of Uganda in 2010?
Your answer should be very brief. 5.28e+1. What is the difference between the Expenses (in $) in Kyrgyz Republic in 2009 and the Expenses (in $) in Oman in 2010?
Your answer should be very brief. 1.04e+1. What is the difference between the Expenses (in $) in Kyrgyz Republic in 2009 and the Expenses (in $) in Uganda in 2010?
Make the answer very short. -1.19e+12. What is the difference between the Expenses (in $) in Oman in 2009 and the Expenses (in $) in Uganda in 2010?
Offer a terse response. -1.20e+12. What is the average Expenses (in $) in Hungary per year?
Provide a short and direct response. 8.38e+11. What is the average Expenses (in $) in Kyrgyz Republic per year?
Offer a terse response. 8.07e+09. What is the average Expenses (in $) of Oman per year?
Make the answer very short. 4.50e+09. What is the average Expenses (in $) in Uganda per year?
Keep it short and to the point. 9.18e+11. In the year 1999, what is the difference between the Expenses (in $) of Hungary and Expenses (in $) of Kyrgyz Republic?
Your answer should be very brief. 3.41e+11. In the year 1999, what is the difference between the Expenses (in $) of Hungary and Expenses (in $) of Oman?
Your response must be concise. 3.42e+11. In the year 1999, what is the difference between the Expenses (in $) of Hungary and Expenses (in $) of Uganda?
Your answer should be compact. -7.86e+1. In the year 1999, what is the difference between the Expenses (in $) of Kyrgyz Republic and Expenses (in $) of Oman?
Provide a succinct answer. 1.05e+09. In the year 1999, what is the difference between the Expenses (in $) in Kyrgyz Republic and Expenses (in $) in Uganda?
Provide a short and direct response. -4.20e+11. In the year 1999, what is the difference between the Expenses (in $) in Oman and Expenses (in $) in Uganda?
Ensure brevity in your answer.  -4.21e+11. In the year 2000, what is the difference between the Expenses (in $) of Hungary and Expenses (in $) of Kyrgyz Republic?
Give a very brief answer. 3.86e+11. In the year 2000, what is the difference between the Expenses (in $) of Hungary and Expenses (in $) of Oman?
Offer a very short reply. 3.86e+11. In the year 2000, what is the difference between the Expenses (in $) of Hungary and Expenses (in $) of Uganda?
Offer a terse response. -2.30e+11. In the year 2000, what is the difference between the Expenses (in $) of Kyrgyz Republic and Expenses (in $) of Oman?
Your answer should be very brief. 6.11e+07. In the year 2000, what is the difference between the Expenses (in $) of Kyrgyz Republic and Expenses (in $) of Uganda?
Your answer should be very brief. -6.16e+11. In the year 2000, what is the difference between the Expenses (in $) of Oman and Expenses (in $) of Uganda?
Your answer should be compact. -6.16e+11. In the year 2001, what is the difference between the Expenses (in $) in Hungary and Expenses (in $) in Kyrgyz Republic?
Make the answer very short. 4.55e+11. In the year 2001, what is the difference between the Expenses (in $) of Hungary and Expenses (in $) of Oman?
Your answer should be compact. 4.56e+11. In the year 2001, what is the difference between the Expenses (in $) in Hungary and Expenses (in $) in Uganda?
Make the answer very short. -9.99e+11. In the year 2001, what is the difference between the Expenses (in $) in Kyrgyz Republic and Expenses (in $) in Oman?
Ensure brevity in your answer.  9.12e+08. In the year 2001, what is the difference between the Expenses (in $) of Kyrgyz Republic and Expenses (in $) of Uganda?
Provide a succinct answer. -1.45e+12. In the year 2001, what is the difference between the Expenses (in $) in Oman and Expenses (in $) in Uganda?
Offer a terse response. -1.45e+12. In the year 2006, what is the difference between the Expenses (in $) in Hungary and Expenses (in $) in Kyrgyz Republic?
Provide a succinct answer. 9.02e+11. In the year 2006, what is the difference between the Expenses (in $) in Hungary and Expenses (in $) in Oman?
Give a very brief answer. 9.00e+11. In the year 2006, what is the difference between the Expenses (in $) of Hungary and Expenses (in $) of Uganda?
Offer a terse response. -7.31e+1. In the year 2006, what is the difference between the Expenses (in $) of Kyrgyz Republic and Expenses (in $) of Oman?
Offer a very short reply. -1.73e+09. In the year 2006, what is the difference between the Expenses (in $) in Kyrgyz Republic and Expenses (in $) in Uganda?
Give a very brief answer. -9.75e+11. In the year 2006, what is the difference between the Expenses (in $) of Oman and Expenses (in $) of Uganda?
Offer a very short reply. -9.73e+11. In the year 2007, what is the difference between the Expenses (in $) of Hungary and Expenses (in $) of Kyrgyz Republic?
Give a very brief answer. 9.04e+11. In the year 2007, what is the difference between the Expenses (in $) of Hungary and Expenses (in $) of Oman?
Your answer should be very brief. 9.08e+11. In the year 2007, what is the difference between the Expenses (in $) of Hungary and Expenses (in $) of Uganda?
Offer a very short reply. 8.40e+1. In the year 2007, what is the difference between the Expenses (in $) of Kyrgyz Republic and Expenses (in $) of Oman?
Your response must be concise. 4.00e+09. In the year 2007, what is the difference between the Expenses (in $) of Kyrgyz Republic and Expenses (in $) of Uganda?
Make the answer very short. -8.20e+11. In the year 2007, what is the difference between the Expenses (in $) of Oman and Expenses (in $) of Uganda?
Provide a succinct answer. -8.24e+11. In the year 2008, what is the difference between the Expenses (in $) of Hungary and Expenses (in $) of Kyrgyz Republic?
Give a very brief answer. 1.01e+12. In the year 2008, what is the difference between the Expenses (in $) in Hungary and Expenses (in $) in Oman?
Your answer should be compact. 1.01e+12. In the year 2008, what is the difference between the Expenses (in $) of Hungary and Expenses (in $) of Uganda?
Offer a very short reply. 1.94e+11. In the year 2008, what is the difference between the Expenses (in $) of Kyrgyz Republic and Expenses (in $) of Oman?
Provide a short and direct response. 3.25e+09. In the year 2008, what is the difference between the Expenses (in $) in Kyrgyz Republic and Expenses (in $) in Uganda?
Your answer should be compact. -8.14e+11. In the year 2008, what is the difference between the Expenses (in $) of Oman and Expenses (in $) of Uganda?
Offer a very short reply. -8.17e+11. In the year 2009, what is the difference between the Expenses (in $) in Hungary and Expenses (in $) in Kyrgyz Republic?
Offer a terse response. 1.24e+12. In the year 2009, what is the difference between the Expenses (in $) of Hungary and Expenses (in $) of Oman?
Offer a very short reply. 1.25e+12. In the year 2009, what is the difference between the Expenses (in $) in Hungary and Expenses (in $) in Uganda?
Offer a very short reply. 2.51e+11. In the year 2009, what is the difference between the Expenses (in $) of Kyrgyz Republic and Expenses (in $) of Oman?
Provide a succinct answer. 1.16e+1. In the year 2009, what is the difference between the Expenses (in $) of Kyrgyz Republic and Expenses (in $) of Uganda?
Keep it short and to the point. -9.91e+11. In the year 2009, what is the difference between the Expenses (in $) in Oman and Expenses (in $) in Uganda?
Keep it short and to the point. -1.00e+12. In the year 2010, what is the difference between the Expenses (in $) of Hungary and Expenses (in $) of Kyrgyz Republic?
Provide a short and direct response. 1.40e+12. In the year 2010, what is the difference between the Expenses (in $) of Hungary and Expenses (in $) of Oman?
Your answer should be very brief. 1.41e+12. In the year 2010, what is the difference between the Expenses (in $) of Hungary and Expenses (in $) of Uganda?
Provide a short and direct response. 2.09e+11. In the year 2010, what is the difference between the Expenses (in $) of Kyrgyz Republic and Expenses (in $) of Oman?
Your answer should be very brief. 9.40e+09. In the year 2010, what is the difference between the Expenses (in $) of Kyrgyz Republic and Expenses (in $) of Uganda?
Offer a very short reply. -1.19e+12. In the year 2010, what is the difference between the Expenses (in $) of Oman and Expenses (in $) of Uganda?
Your response must be concise. -1.20e+12. What is the ratio of the Expenses (in $) of Hungary in 1999 to that in 2000?
Provide a succinct answer. 0.89. What is the ratio of the Expenses (in $) in Kyrgyz Republic in 1999 to that in 2000?
Make the answer very short. 0.94. What is the ratio of the Expenses (in $) in Oman in 1999 to that in 2000?
Your answer should be compact. 0.47. What is the ratio of the Expenses (in $) in Uganda in 1999 to that in 2000?
Provide a short and direct response. 0.68. What is the ratio of the Expenses (in $) of Hungary in 1999 to that in 2001?
Offer a very short reply. 0.75. What is the ratio of the Expenses (in $) of Kyrgyz Republic in 1999 to that in 2001?
Offer a very short reply. 0.62. What is the ratio of the Expenses (in $) of Oman in 1999 to that in 2001?
Provide a short and direct response. 0.42. What is the ratio of the Expenses (in $) of Uganda in 1999 to that in 2001?
Make the answer very short. 0.29. What is the ratio of the Expenses (in $) of Hungary in 1999 to that in 2006?
Offer a very short reply. 0.38. What is the ratio of the Expenses (in $) of Kyrgyz Republic in 1999 to that in 2006?
Provide a short and direct response. 0.71. What is the ratio of the Expenses (in $) in Oman in 1999 to that in 2006?
Your answer should be compact. 0.21. What is the ratio of the Expenses (in $) in Uganda in 1999 to that in 2006?
Make the answer very short. 0.43. What is the ratio of the Expenses (in $) in Hungary in 1999 to that in 2007?
Keep it short and to the point. 0.38. What is the ratio of the Expenses (in $) of Kyrgyz Republic in 1999 to that in 2007?
Offer a terse response. 0.22. What is the ratio of the Expenses (in $) of Oman in 1999 to that in 2007?
Your response must be concise. 0.18. What is the ratio of the Expenses (in $) in Uganda in 1999 to that in 2007?
Provide a short and direct response. 0.51. What is the ratio of the Expenses (in $) of Hungary in 1999 to that in 2008?
Your response must be concise. 0.34. What is the ratio of the Expenses (in $) in Kyrgyz Republic in 1999 to that in 2008?
Your answer should be compact. 0.2. What is the ratio of the Expenses (in $) of Oman in 1999 to that in 2008?
Provide a short and direct response. 0.14. What is the ratio of the Expenses (in $) of Uganda in 1999 to that in 2008?
Provide a short and direct response. 0.51. What is the ratio of the Expenses (in $) in Hungary in 1999 to that in 2009?
Your response must be concise. 0.27. What is the ratio of the Expenses (in $) of Kyrgyz Republic in 1999 to that in 2009?
Your answer should be very brief. 0.12. What is the ratio of the Expenses (in $) of Oman in 1999 to that in 2009?
Your answer should be compact. 0.16. What is the ratio of the Expenses (in $) of Uganda in 1999 to that in 2009?
Offer a terse response. 0.42. What is the ratio of the Expenses (in $) of Hungary in 1999 to that in 2010?
Ensure brevity in your answer.  0.24. What is the ratio of the Expenses (in $) in Kyrgyz Republic in 1999 to that in 2010?
Make the answer very short. 0.12. What is the ratio of the Expenses (in $) in Oman in 1999 to that in 2010?
Make the answer very short. 0.14. What is the ratio of the Expenses (in $) in Uganda in 1999 to that in 2010?
Provide a short and direct response. 0.35. What is the ratio of the Expenses (in $) of Hungary in 2000 to that in 2001?
Give a very brief answer. 0.85. What is the ratio of the Expenses (in $) in Kyrgyz Republic in 2000 to that in 2001?
Provide a succinct answer. 0.66. What is the ratio of the Expenses (in $) of Oman in 2000 to that in 2001?
Your answer should be compact. 0.89. What is the ratio of the Expenses (in $) in Uganda in 2000 to that in 2001?
Provide a short and direct response. 0.42. What is the ratio of the Expenses (in $) in Hungary in 2000 to that in 2006?
Your answer should be very brief. 0.43. What is the ratio of the Expenses (in $) of Kyrgyz Republic in 2000 to that in 2006?
Provide a short and direct response. 0.75. What is the ratio of the Expenses (in $) in Oman in 2000 to that in 2006?
Make the answer very short. 0.46. What is the ratio of the Expenses (in $) of Uganda in 2000 to that in 2006?
Your answer should be very brief. 0.63. What is the ratio of the Expenses (in $) of Hungary in 2000 to that in 2007?
Provide a succinct answer. 0.42. What is the ratio of the Expenses (in $) of Kyrgyz Republic in 2000 to that in 2007?
Your response must be concise. 0.23. What is the ratio of the Expenses (in $) in Oman in 2000 to that in 2007?
Your response must be concise. 0.39. What is the ratio of the Expenses (in $) in Uganda in 2000 to that in 2007?
Ensure brevity in your answer.  0.75. What is the ratio of the Expenses (in $) in Hungary in 2000 to that in 2008?
Make the answer very short. 0.38. What is the ratio of the Expenses (in $) in Kyrgyz Republic in 2000 to that in 2008?
Ensure brevity in your answer.  0.21. What is the ratio of the Expenses (in $) in Oman in 2000 to that in 2008?
Offer a very short reply. 0.3. What is the ratio of the Expenses (in $) in Uganda in 2000 to that in 2008?
Keep it short and to the point. 0.75. What is the ratio of the Expenses (in $) in Hungary in 2000 to that in 2009?
Make the answer very short. 0.31. What is the ratio of the Expenses (in $) in Kyrgyz Republic in 2000 to that in 2009?
Offer a very short reply. 0.12. What is the ratio of the Expenses (in $) of Oman in 2000 to that in 2009?
Your response must be concise. 0.35. What is the ratio of the Expenses (in $) of Uganda in 2000 to that in 2009?
Your response must be concise. 0.61. What is the ratio of the Expenses (in $) in Hungary in 2000 to that in 2010?
Offer a terse response. 0.27. What is the ratio of the Expenses (in $) of Kyrgyz Republic in 2000 to that in 2010?
Your answer should be very brief. 0.13. What is the ratio of the Expenses (in $) in Oman in 2000 to that in 2010?
Your response must be concise. 0.29. What is the ratio of the Expenses (in $) of Uganda in 2000 to that in 2010?
Keep it short and to the point. 0.51. What is the ratio of the Expenses (in $) in Hungary in 2001 to that in 2006?
Your answer should be compact. 0.51. What is the ratio of the Expenses (in $) of Kyrgyz Republic in 2001 to that in 2006?
Your answer should be very brief. 1.13. What is the ratio of the Expenses (in $) of Oman in 2001 to that in 2006?
Offer a terse response. 0.51. What is the ratio of the Expenses (in $) of Uganda in 2001 to that in 2006?
Give a very brief answer. 1.49. What is the ratio of the Expenses (in $) in Hungary in 2001 to that in 2007?
Your response must be concise. 0.5. What is the ratio of the Expenses (in $) in Kyrgyz Republic in 2001 to that in 2007?
Offer a very short reply. 0.35. What is the ratio of the Expenses (in $) in Oman in 2001 to that in 2007?
Provide a short and direct response. 0.44. What is the ratio of the Expenses (in $) of Uganda in 2001 to that in 2007?
Make the answer very short. 1.76. What is the ratio of the Expenses (in $) in Hungary in 2001 to that in 2008?
Provide a succinct answer. 0.45. What is the ratio of the Expenses (in $) of Kyrgyz Republic in 2001 to that in 2008?
Offer a terse response. 0.32. What is the ratio of the Expenses (in $) of Oman in 2001 to that in 2008?
Offer a terse response. 0.34. What is the ratio of the Expenses (in $) in Uganda in 2001 to that in 2008?
Keep it short and to the point. 1.77. What is the ratio of the Expenses (in $) of Hungary in 2001 to that in 2009?
Keep it short and to the point. 0.36. What is the ratio of the Expenses (in $) in Kyrgyz Republic in 2001 to that in 2009?
Your response must be concise. 0.19. What is the ratio of the Expenses (in $) in Oman in 2001 to that in 2009?
Your answer should be compact. 0.39. What is the ratio of the Expenses (in $) in Uganda in 2001 to that in 2009?
Offer a very short reply. 1.44. What is the ratio of the Expenses (in $) of Hungary in 2001 to that in 2010?
Ensure brevity in your answer.  0.32. What is the ratio of the Expenses (in $) of Kyrgyz Republic in 2001 to that in 2010?
Your response must be concise. 0.2. What is the ratio of the Expenses (in $) of Oman in 2001 to that in 2010?
Your answer should be compact. 0.33. What is the ratio of the Expenses (in $) in Uganda in 2001 to that in 2010?
Your answer should be very brief. 1.21. What is the ratio of the Expenses (in $) of Kyrgyz Republic in 2006 to that in 2007?
Your response must be concise. 0.31. What is the ratio of the Expenses (in $) of Oman in 2006 to that in 2007?
Keep it short and to the point. 0.86. What is the ratio of the Expenses (in $) in Uganda in 2006 to that in 2007?
Provide a short and direct response. 1.18. What is the ratio of the Expenses (in $) in Hungary in 2006 to that in 2008?
Your answer should be compact. 0.89. What is the ratio of the Expenses (in $) in Kyrgyz Republic in 2006 to that in 2008?
Offer a very short reply. 0.28. What is the ratio of the Expenses (in $) in Oman in 2006 to that in 2008?
Your response must be concise. 0.66. What is the ratio of the Expenses (in $) in Uganda in 2006 to that in 2008?
Offer a very short reply. 1.19. What is the ratio of the Expenses (in $) in Hungary in 2006 to that in 2009?
Offer a very short reply. 0.72. What is the ratio of the Expenses (in $) of Kyrgyz Republic in 2006 to that in 2009?
Your answer should be compact. 0.16. What is the ratio of the Expenses (in $) in Oman in 2006 to that in 2009?
Make the answer very short. 0.76. What is the ratio of the Expenses (in $) of Uganda in 2006 to that in 2009?
Offer a very short reply. 0.97. What is the ratio of the Expenses (in $) in Hungary in 2006 to that in 2010?
Give a very brief answer. 0.64. What is the ratio of the Expenses (in $) of Kyrgyz Republic in 2006 to that in 2010?
Ensure brevity in your answer.  0.17. What is the ratio of the Expenses (in $) of Oman in 2006 to that in 2010?
Provide a succinct answer. 0.63. What is the ratio of the Expenses (in $) of Uganda in 2006 to that in 2010?
Provide a succinct answer. 0.81. What is the ratio of the Expenses (in $) of Hungary in 2007 to that in 2008?
Offer a very short reply. 0.9. What is the ratio of the Expenses (in $) in Kyrgyz Republic in 2007 to that in 2008?
Offer a terse response. 0.92. What is the ratio of the Expenses (in $) in Oman in 2007 to that in 2008?
Your answer should be very brief. 0.77. What is the ratio of the Expenses (in $) of Hungary in 2007 to that in 2009?
Provide a short and direct response. 0.73. What is the ratio of the Expenses (in $) in Kyrgyz Republic in 2007 to that in 2009?
Provide a succinct answer. 0.53. What is the ratio of the Expenses (in $) of Oman in 2007 to that in 2009?
Provide a succinct answer. 0.88. What is the ratio of the Expenses (in $) in Uganda in 2007 to that in 2009?
Make the answer very short. 0.82. What is the ratio of the Expenses (in $) of Hungary in 2007 to that in 2010?
Your response must be concise. 0.65. What is the ratio of the Expenses (in $) of Kyrgyz Republic in 2007 to that in 2010?
Your answer should be compact. 0.56. What is the ratio of the Expenses (in $) of Oman in 2007 to that in 2010?
Provide a short and direct response. 0.74. What is the ratio of the Expenses (in $) of Uganda in 2007 to that in 2010?
Your response must be concise. 0.69. What is the ratio of the Expenses (in $) in Hungary in 2008 to that in 2009?
Keep it short and to the point. 0.81. What is the ratio of the Expenses (in $) in Kyrgyz Republic in 2008 to that in 2009?
Your response must be concise. 0.58. What is the ratio of the Expenses (in $) of Oman in 2008 to that in 2009?
Keep it short and to the point. 1.14. What is the ratio of the Expenses (in $) in Uganda in 2008 to that in 2009?
Offer a terse response. 0.82. What is the ratio of the Expenses (in $) of Hungary in 2008 to that in 2010?
Offer a terse response. 0.72. What is the ratio of the Expenses (in $) in Kyrgyz Republic in 2008 to that in 2010?
Offer a terse response. 0.61. What is the ratio of the Expenses (in $) of Oman in 2008 to that in 2010?
Offer a very short reply. 0.96. What is the ratio of the Expenses (in $) of Uganda in 2008 to that in 2010?
Ensure brevity in your answer.  0.68. What is the ratio of the Expenses (in $) in Hungary in 2009 to that in 2010?
Your answer should be very brief. 0.89. What is the ratio of the Expenses (in $) in Kyrgyz Republic in 2009 to that in 2010?
Offer a terse response. 1.06. What is the ratio of the Expenses (in $) of Oman in 2009 to that in 2010?
Your answer should be very brief. 0.84. What is the ratio of the Expenses (in $) in Uganda in 2009 to that in 2010?
Ensure brevity in your answer.  0.84. What is the difference between the highest and the second highest Expenses (in $) of Hungary?
Give a very brief answer. 1.57e+11. What is the difference between the highest and the second highest Expenses (in $) in Kyrgyz Republic?
Provide a short and direct response. 1.05e+09. What is the difference between the highest and the second highest Expenses (in $) of Oman?
Provide a short and direct response. 2.88e+08. What is the difference between the highest and the second highest Expenses (in $) in Uganda?
Make the answer very short. 2.50e+11. What is the difference between the highest and the lowest Expenses (in $) in Hungary?
Your answer should be compact. 1.07e+12. What is the difference between the highest and the lowest Expenses (in $) of Kyrgyz Republic?
Ensure brevity in your answer.  1.57e+1. What is the difference between the highest and the lowest Expenses (in $) of Oman?
Provide a short and direct response. 6.31e+09. What is the difference between the highest and the lowest Expenses (in $) of Uganda?
Make the answer very short. 1.04e+12. 